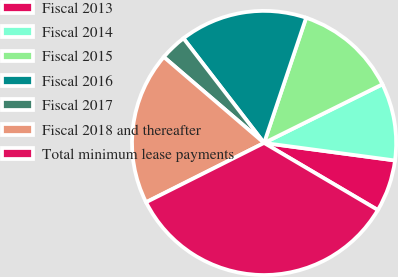Convert chart to OTSL. <chart><loc_0><loc_0><loc_500><loc_500><pie_chart><fcel>Fiscal 2013<fcel>Fiscal 2014<fcel>Fiscal 2015<fcel>Fiscal 2016<fcel>Fiscal 2017<fcel>Fiscal 2018 and thereafter<fcel>Total minimum lease payments<nl><fcel>6.36%<fcel>9.44%<fcel>12.52%<fcel>15.61%<fcel>3.27%<fcel>18.69%<fcel>34.11%<nl></chart> 